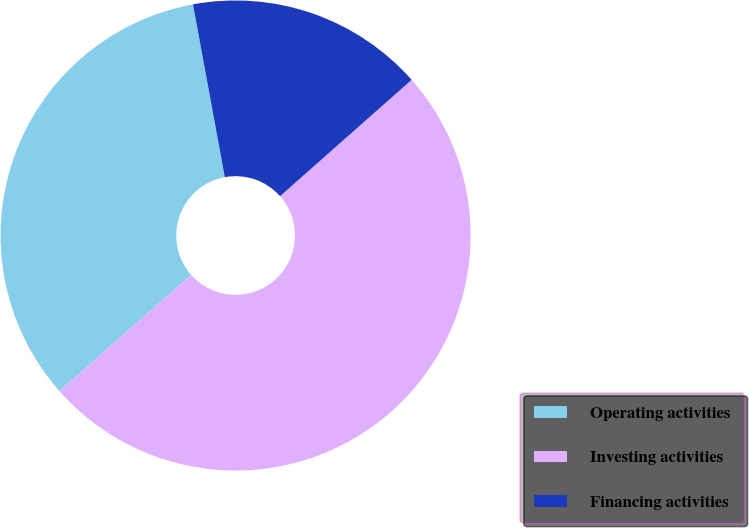<chart> <loc_0><loc_0><loc_500><loc_500><pie_chart><fcel>Operating activities<fcel>Investing activities<fcel>Financing activities<nl><fcel>33.62%<fcel>50.01%<fcel>16.38%<nl></chart> 